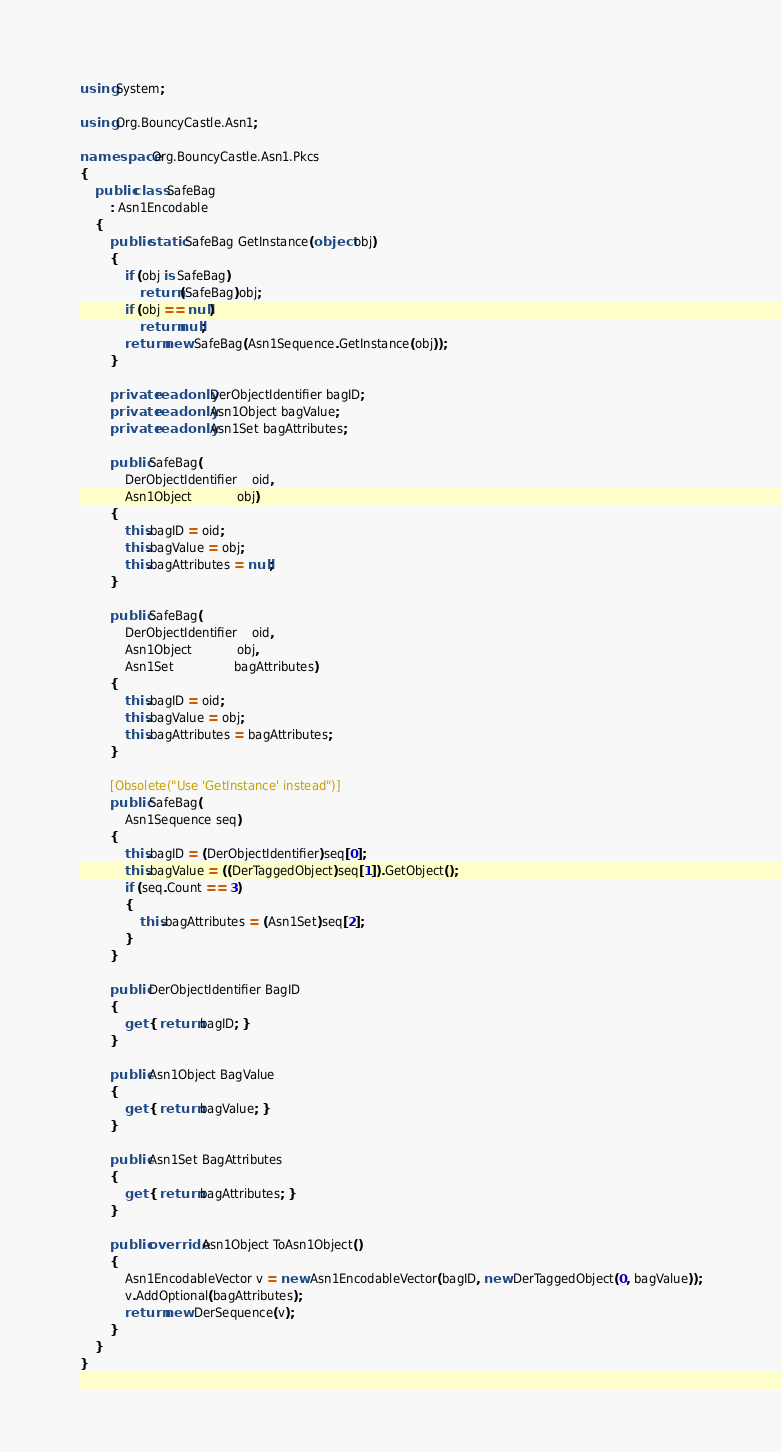<code> <loc_0><loc_0><loc_500><loc_500><_C#_>using System;

using Org.BouncyCastle.Asn1;

namespace Org.BouncyCastle.Asn1.Pkcs
{
    public class SafeBag
        : Asn1Encodable
    {
        public static SafeBag GetInstance(object obj)
        {
            if (obj is SafeBag)
                return (SafeBag)obj;
            if (obj == null)
                return null;
            return new SafeBag(Asn1Sequence.GetInstance(obj));
        }

        private readonly DerObjectIdentifier bagID;
        private readonly Asn1Object bagValue;
        private readonly Asn1Set bagAttributes;

		public SafeBag(
            DerObjectIdentifier	oid,
            Asn1Object			obj)
        {
            this.bagID = oid;
            this.bagValue = obj;
            this.bagAttributes = null;
        }

		public SafeBag(
            DerObjectIdentifier	oid,
            Asn1Object			obj,
            Asn1Set				bagAttributes)
        {
            this.bagID = oid;
            this.bagValue = obj;
            this.bagAttributes = bagAttributes;
        }

        [Obsolete("Use 'GetInstance' instead")]
		public SafeBag(
            Asn1Sequence seq)
        {
            this.bagID = (DerObjectIdentifier)seq[0];
            this.bagValue = ((DerTaggedObject)seq[1]).GetObject();
            if (seq.Count == 3)
            {
                this.bagAttributes = (Asn1Set)seq[2];
            }
        }

		public DerObjectIdentifier BagID
		{
			get { return bagID; }
		}

		public Asn1Object BagValue
		{
			get { return bagValue; }
		}

		public Asn1Set BagAttributes
		{
			get { return bagAttributes; }
		}

        public override Asn1Object ToAsn1Object()
        {
            Asn1EncodableVector v = new Asn1EncodableVector(bagID, new DerTaggedObject(0, bagValue));
            v.AddOptional(bagAttributes);
            return new DerSequence(v);
        }
    }
}
</code> 